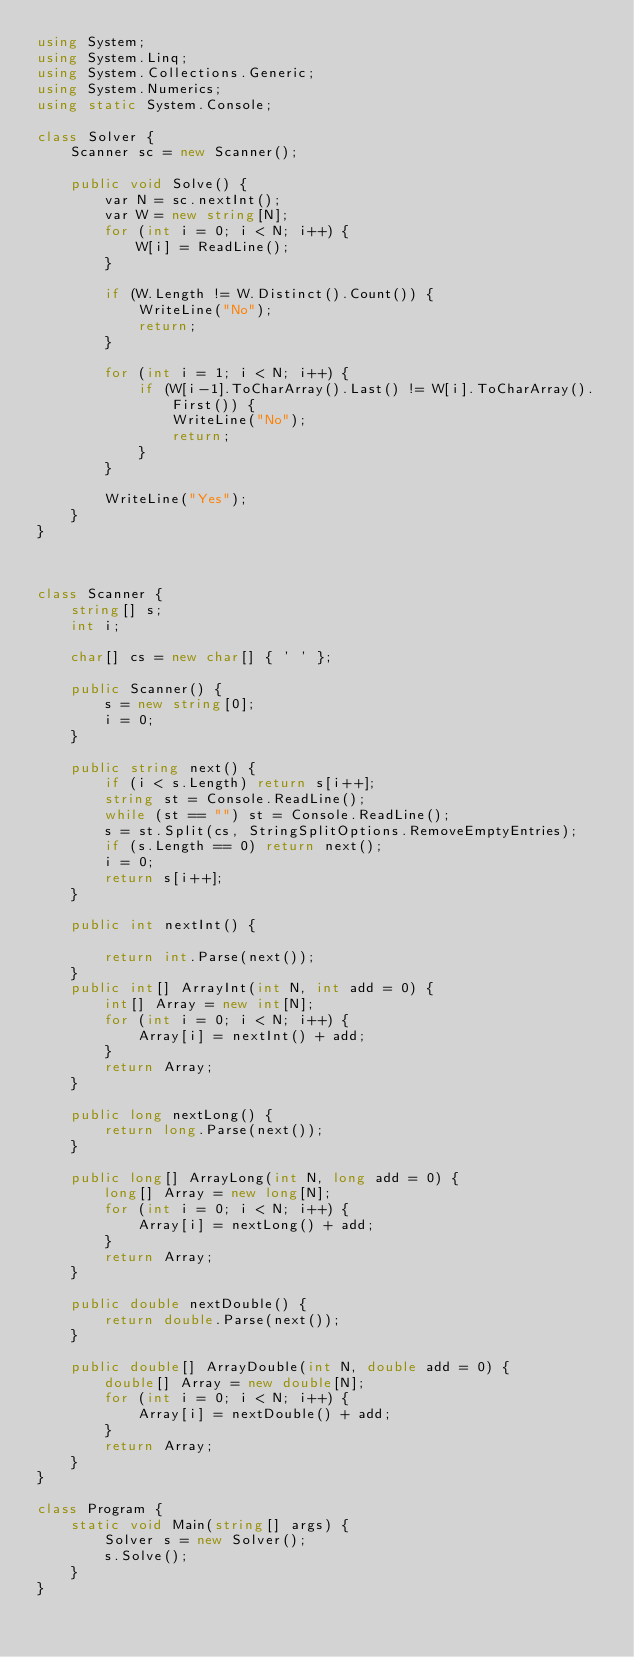Convert code to text. <code><loc_0><loc_0><loc_500><loc_500><_C#_>using System;
using System.Linq;
using System.Collections.Generic;
using System.Numerics;
using static System.Console;

class Solver {
    Scanner sc = new Scanner();

    public void Solve() {
        var N = sc.nextInt();
        var W = new string[N];
        for (int i = 0; i < N; i++) {
            W[i] = ReadLine();
        }

        if (W.Length != W.Distinct().Count()) {
            WriteLine("No");
            return;
        }

        for (int i = 1; i < N; i++) {
            if (W[i-1].ToCharArray().Last() != W[i].ToCharArray().First()) {
                WriteLine("No");
                return;
            }
        }

        WriteLine("Yes");
    }
}



class Scanner {
    string[] s;
    int i;

    char[] cs = new char[] { ' ' };

    public Scanner() {
        s = new string[0];
        i = 0;
    }

    public string next() {
        if (i < s.Length) return s[i++];
        string st = Console.ReadLine();
        while (st == "") st = Console.ReadLine();
        s = st.Split(cs, StringSplitOptions.RemoveEmptyEntries);
        if (s.Length == 0) return next();
        i = 0;
        return s[i++];
    }

    public int nextInt() {

        return int.Parse(next());
    }
    public int[] ArrayInt(int N, int add = 0) {
        int[] Array = new int[N];
        for (int i = 0; i < N; i++) {
            Array[i] = nextInt() + add;
        }
        return Array;
    }

    public long nextLong() {
        return long.Parse(next());
    }

    public long[] ArrayLong(int N, long add = 0) {
        long[] Array = new long[N];
        for (int i = 0; i < N; i++) {
            Array[i] = nextLong() + add;
        }
        return Array;
    }

    public double nextDouble() {
        return double.Parse(next());
    }

    public double[] ArrayDouble(int N, double add = 0) {
        double[] Array = new double[N];
        for (int i = 0; i < N; i++) {
            Array[i] = nextDouble() + add;
        }
        return Array;
    }
}

class Program {
    static void Main(string[] args) {
        Solver s = new Solver();
        s.Solve();
    }
}</code> 